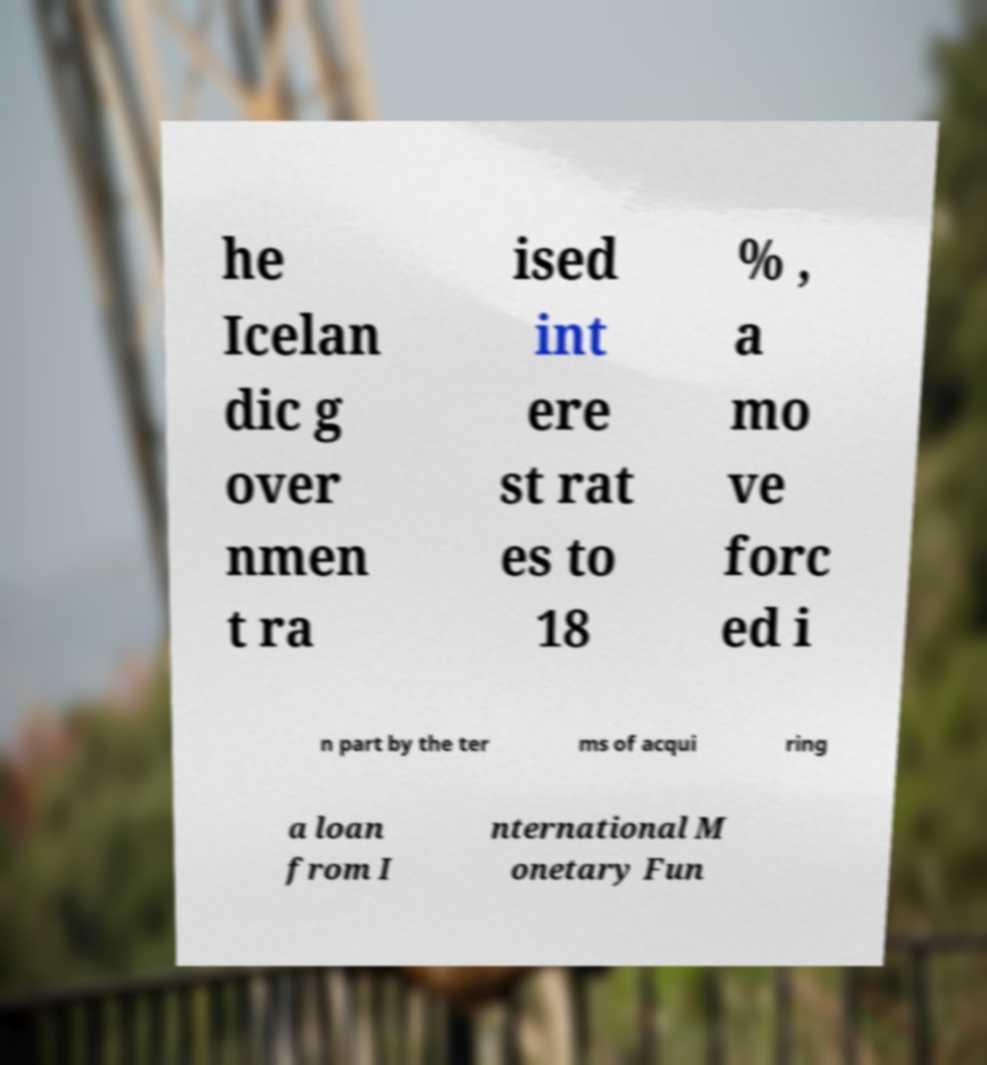What messages or text are displayed in this image? I need them in a readable, typed format. he Icelan dic g over nmen t ra ised int ere st rat es to 18 % , a mo ve forc ed i n part by the ter ms of acqui ring a loan from I nternational M onetary Fun 